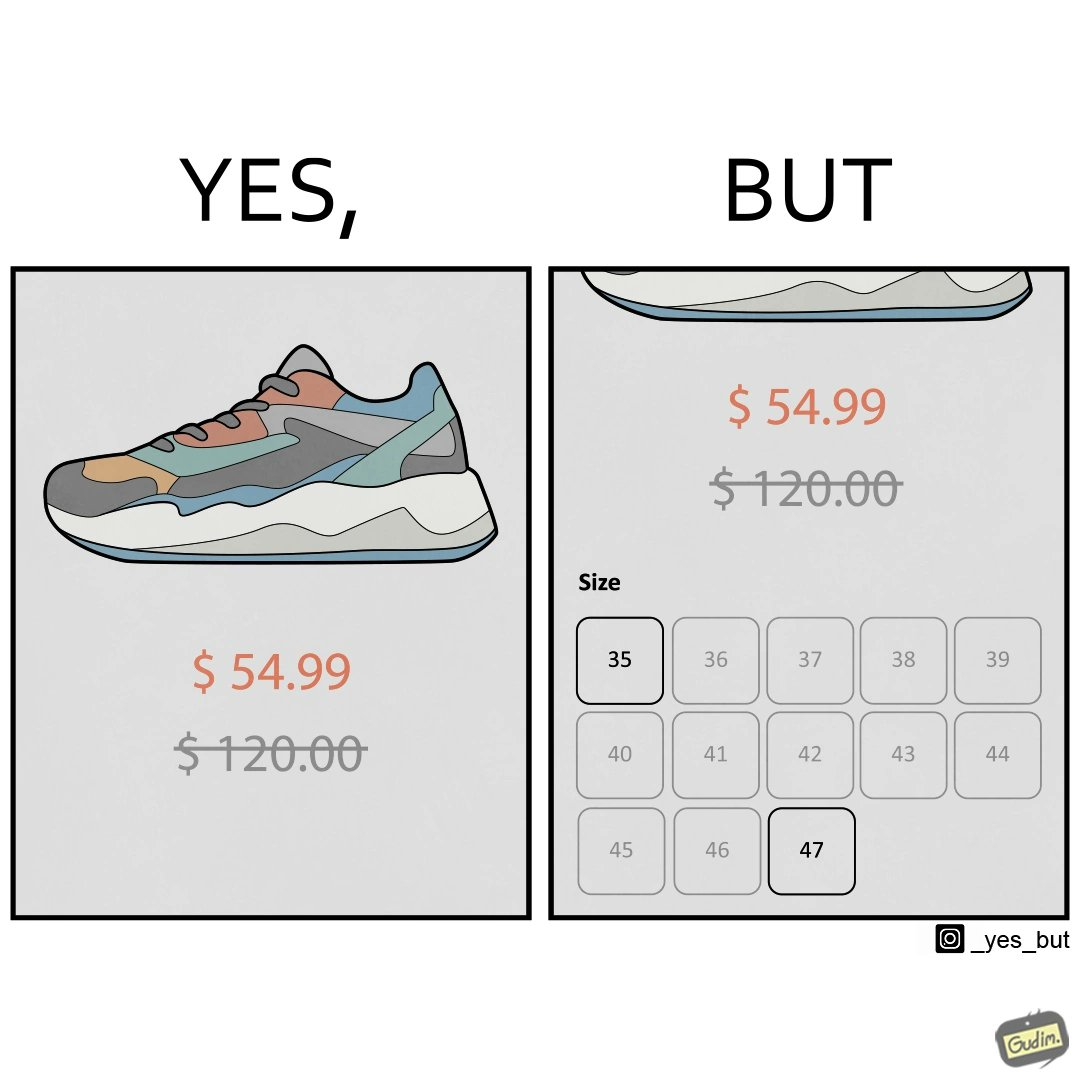Provide a description of this image. The image is funny because while there is a big discount on the shoes inticing customer to buy them, the only available sizes are 35 and 47 which are the smalles and the largest meaning that a majority of the people can not buy the shoe because they won't fit. 